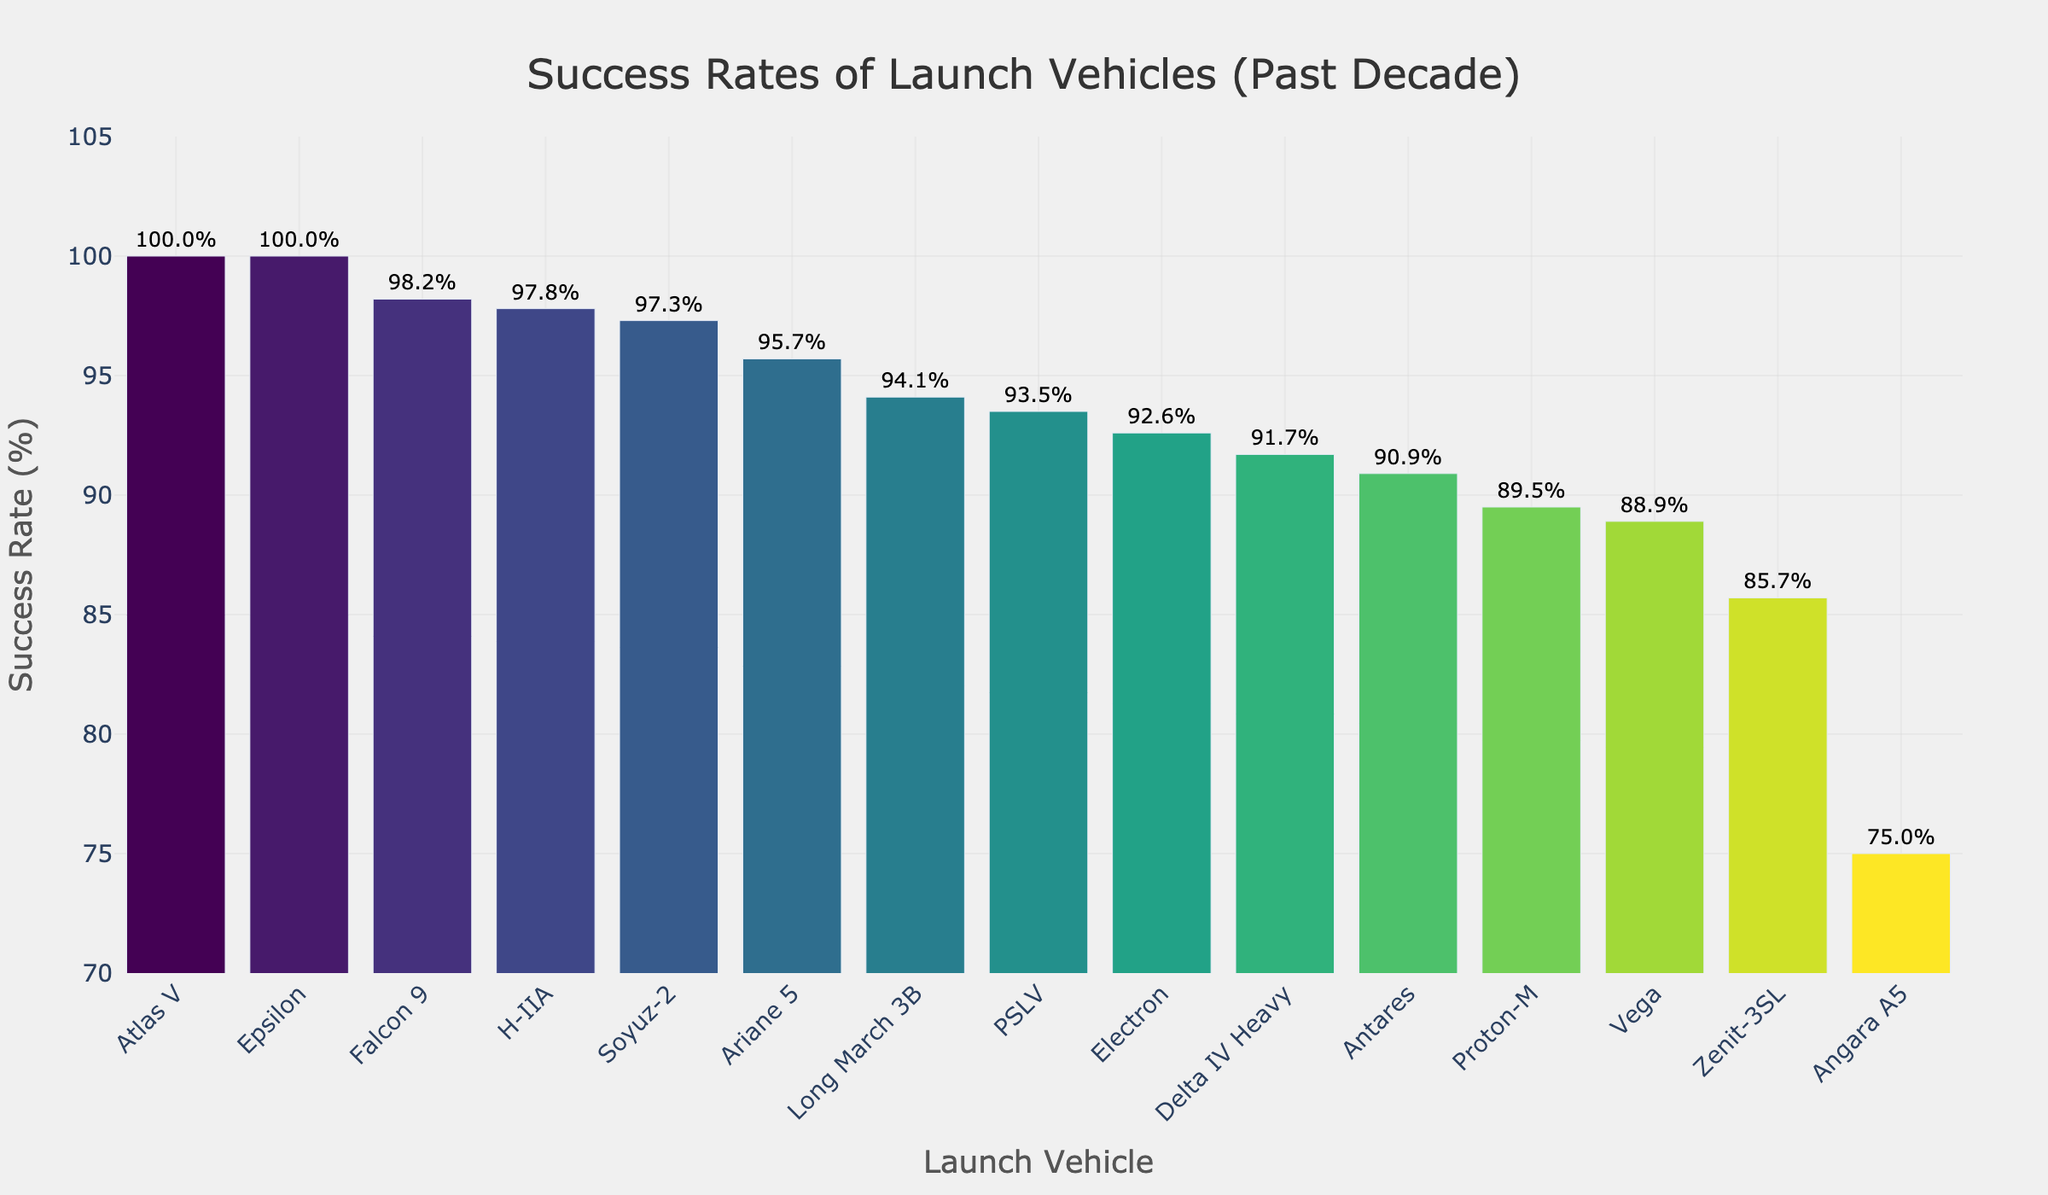Which launch vehicle has the highest success rate? The highest bar represents the vehicle with the highest success rate, observed to be fully filled to the top of the y-axis range. Look for the bar with the highest value.
Answer: Atlas V and Epsilon Which launch vehicle has the lowest success rate? The shortest bar on the chart indicates the vehicle with the lowest success rate. This bar is the least filled compared to others.
Answer: Angara A5 What is the success rate difference between Falcon 9 and Proton-M? Identify the success rates of Falcon 9 (98.2%) and Proton-M (89.5%). Subtract the smaller value from the larger value to find the difference.
Answer: 8.7% Which launch vehicles have over a 95% success rate? Look for bars exceeding the 95% mark on the y-axis. Specifically, check the text labels above the bars.
Answer: Falcon 9, Atlas V, Ariane 5, Soyuz-2, H-IIA How many vehicles have a success rate below 90%? Locate bars that fall under the 90% mark on the y-axis and count them.
Answer: 3 What is the average success rate of Falcon 9, Atlas V, and Soyuz-2? Sum the success rates of Falcon 9 (98.2%), Atlas V (100%), and Soyuz-2 (97.3%), then divide by the number of vehicles (3).
Answer: (98.2 + 100 + 97.3) / 3 = 98.5% Are there any launch vehicles with a 100% success rate? Check the topmost end of the bars marked with 100%.
Answer: Yes, Atlas V and Epsilon What is the success rate range of the launch vehicles displayed? Determine the maximum (100%) and minimum (75%) success rates, then subtract the minimum from the maximum.
Answer: 100% - 75% = 25% What is the success rate of the Electron launch vehicle? Find the bar labeled "Electron" and observe the success rate on its top or side.
Answer: 92.6% Which launch vehicle's success rate is closest to 94%? Identify the bars with success rates around 94%, noting the nearest value to 94%.
Answer: Long March 3B 